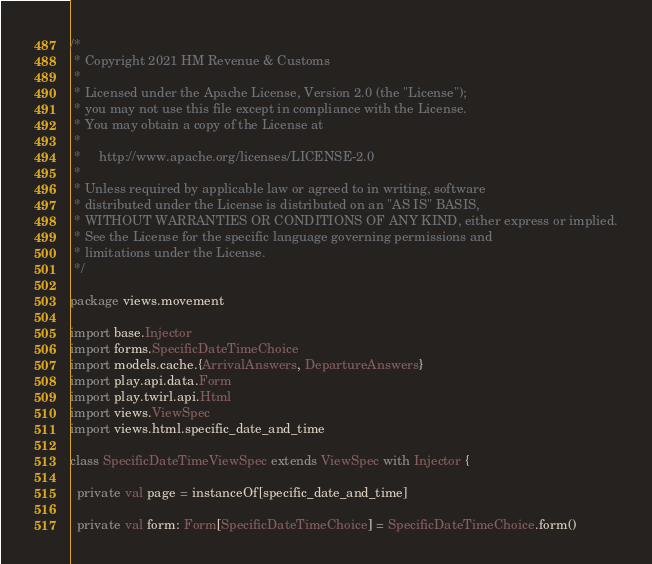<code> <loc_0><loc_0><loc_500><loc_500><_Scala_>/*
 * Copyright 2021 HM Revenue & Customs
 *
 * Licensed under the Apache License, Version 2.0 (the "License");
 * you may not use this file except in compliance with the License.
 * You may obtain a copy of the License at
 *
 *     http://www.apache.org/licenses/LICENSE-2.0
 *
 * Unless required by applicable law or agreed to in writing, software
 * distributed under the License is distributed on an "AS IS" BASIS,
 * WITHOUT WARRANTIES OR CONDITIONS OF ANY KIND, either express or implied.
 * See the License for the specific language governing permissions and
 * limitations under the License.
 */

package views.movement

import base.Injector
import forms.SpecificDateTimeChoice
import models.cache.{ArrivalAnswers, DepartureAnswers}
import play.api.data.Form
import play.twirl.api.Html
import views.ViewSpec
import views.html.specific_date_and_time

class SpecificDateTimeViewSpec extends ViewSpec with Injector {

  private val page = instanceOf[specific_date_and_time]

  private val form: Form[SpecificDateTimeChoice] = SpecificDateTimeChoice.form()</code> 